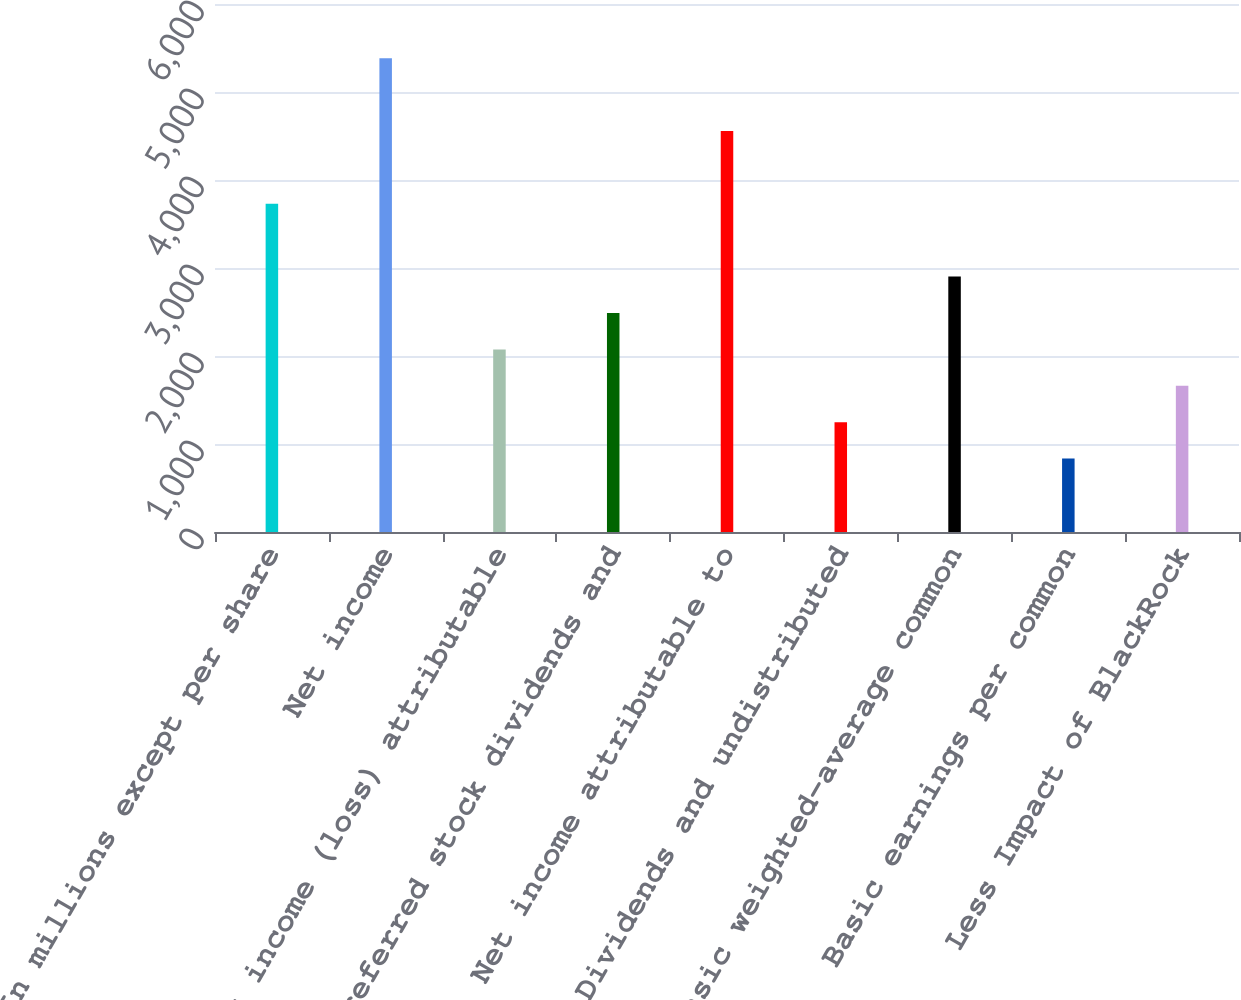Convert chart. <chart><loc_0><loc_0><loc_500><loc_500><bar_chart><fcel>In millions except per share<fcel>Net income<fcel>Net income (loss) attributable<fcel>Preferred stock dividends and<fcel>Net income attributable to<fcel>Dividends and undistributed<fcel>Basic weighted-average common<fcel>Basic earnings per common<fcel>Less Impact of BlackRock<nl><fcel>3729.4<fcel>5383.8<fcel>2075<fcel>2488.6<fcel>4556.6<fcel>1247.8<fcel>2902.2<fcel>834.2<fcel>1661.4<nl></chart> 